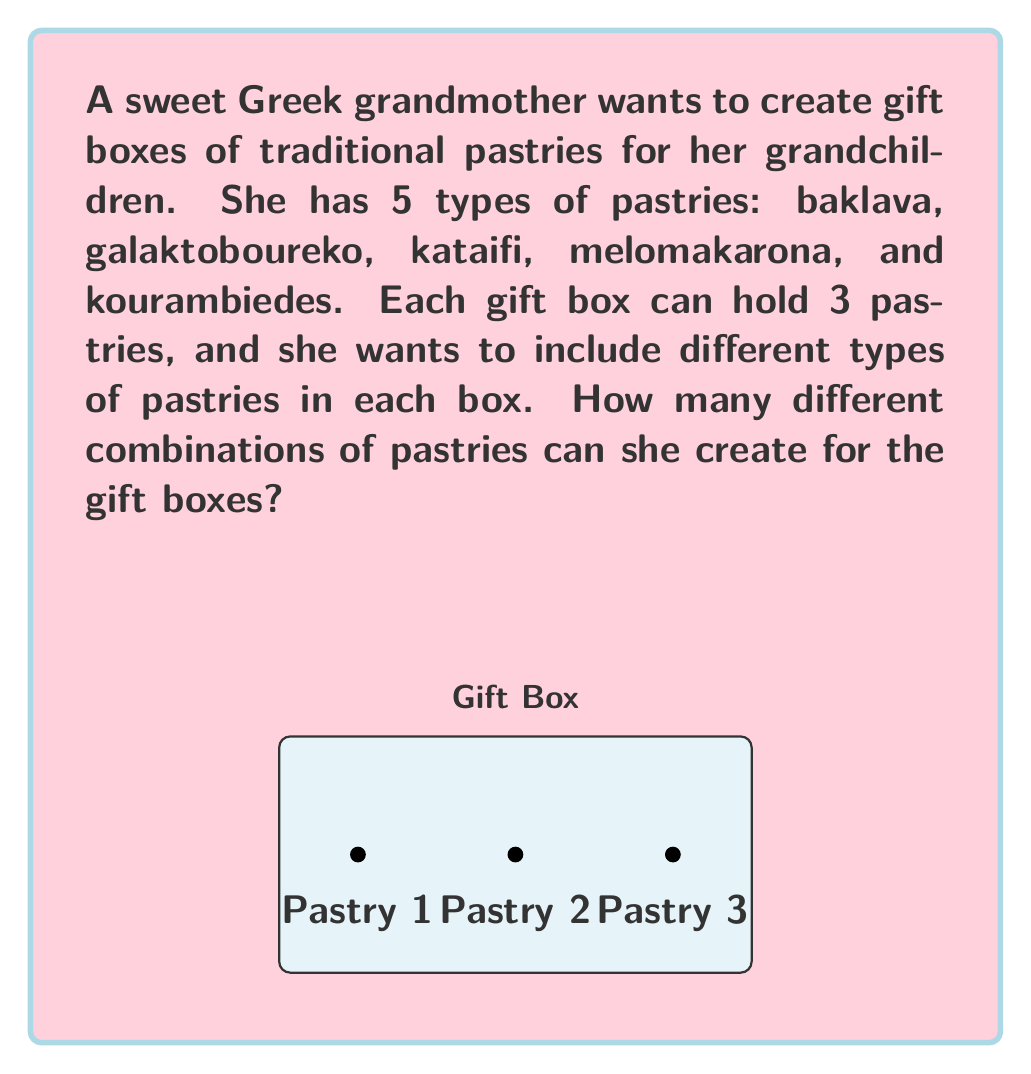Can you solve this math problem? Let's approach this step-by-step:

1) This is a combination problem. We need to select 3 pastries out of 5 types, where the order doesn't matter (it's not important which pastry goes in which spot in the box).

2) The formula for combinations is:

   $$C(n,r) = \frac{n!}{r!(n-r)!}$$

   Where $n$ is the total number of items to choose from, and $r$ is the number of items being chosen.

3) In this case:
   $n = 5$ (total types of pastries)
   $r = 3$ (pastries in each box)

4) Let's substitute these values into our formula:

   $$C(5,3) = \frac{5!}{3!(5-3)!} = \frac{5!}{3!2!}$$

5) Expand this:
   $$\frac{5 * 4 * 3!}{3! * 2 * 1}$$

6) The 3! cancels out in the numerator and denominator:

   $$\frac{5 * 4}{2 * 1} = \frac{20}{2} = 10$$

Therefore, the grandmother can create 10 different combinations of pastries for her gift boxes.
Answer: 10 combinations 